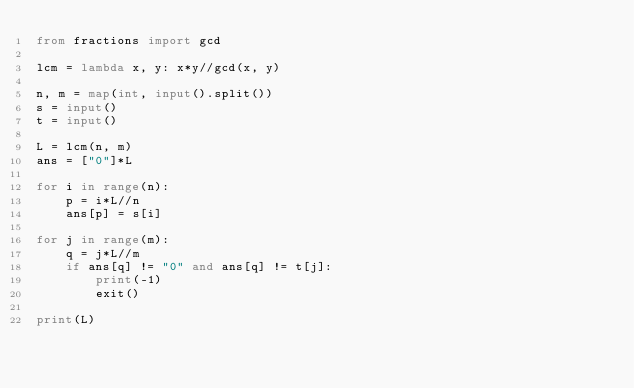<code> <loc_0><loc_0><loc_500><loc_500><_Python_>from fractions import gcd

lcm = lambda x, y: x*y//gcd(x, y)

n, m = map(int, input().split())
s = input()
t = input()

L = lcm(n, m)
ans = ["0"]*L

for i in range(n):
    p = i*L//n
    ans[p] = s[i]

for j in range(m):
    q = j*L//m
    if ans[q] != "0" and ans[q] != t[j]:
        print(-1)
        exit()

print(L)</code> 